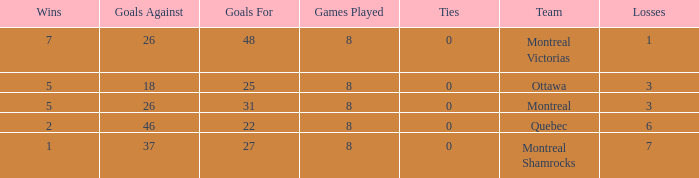For teams with 7 wins, what is the number of goals against? 26.0. 